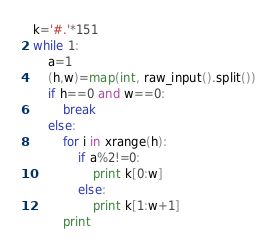Convert code to text. <code><loc_0><loc_0><loc_500><loc_500><_Python_>k='#.'*151
while 1:
    a=1
    (h,w)=map(int, raw_input().split())
    if h==0 and w==0:
        break
    else:
        for i in xrange(h):
            if a%2!=0:
                print k[0:w]
            else:
                print k[1:w+1]
        print </code> 